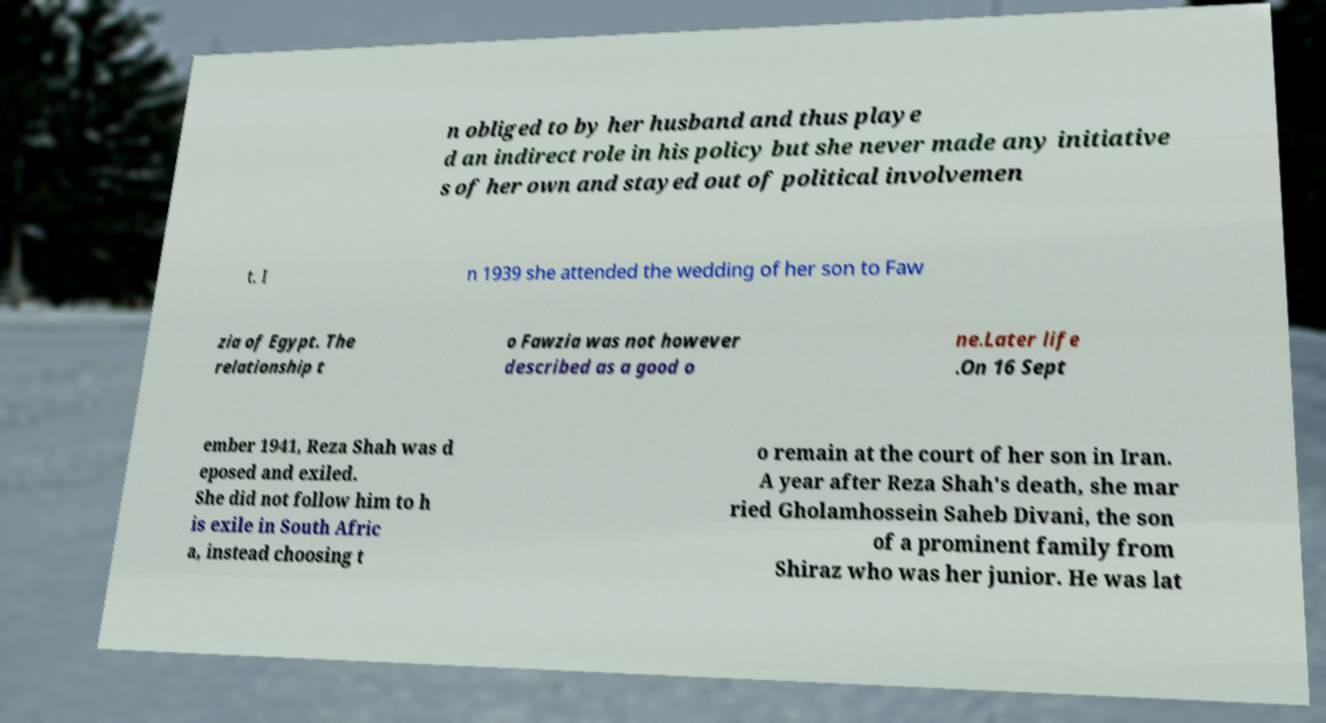Can you accurately transcribe the text from the provided image for me? n obliged to by her husband and thus playe d an indirect role in his policy but she never made any initiative s of her own and stayed out of political involvemen t. I n 1939 she attended the wedding of her son to Faw zia of Egypt. The relationship t o Fawzia was not however described as a good o ne.Later life .On 16 Sept ember 1941, Reza Shah was d eposed and exiled. She did not follow him to h is exile in South Afric a, instead choosing t o remain at the court of her son in Iran. A year after Reza Shah's death, she mar ried Gholamhossein Saheb Divani, the son of a prominent family from Shiraz who was her junior. He was lat 